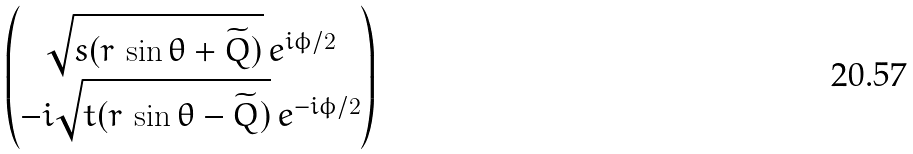Convert formula to latex. <formula><loc_0><loc_0><loc_500><loc_500>\begin{pmatrix} \sqrt { s ( r \, \sin \theta + \widetilde { Q } ) } \, e ^ { i \phi / 2 } \\ - i \sqrt { t ( r \, \sin \theta - \widetilde { Q } ) } \, e ^ { - i \phi / 2 } \end{pmatrix}</formula> 